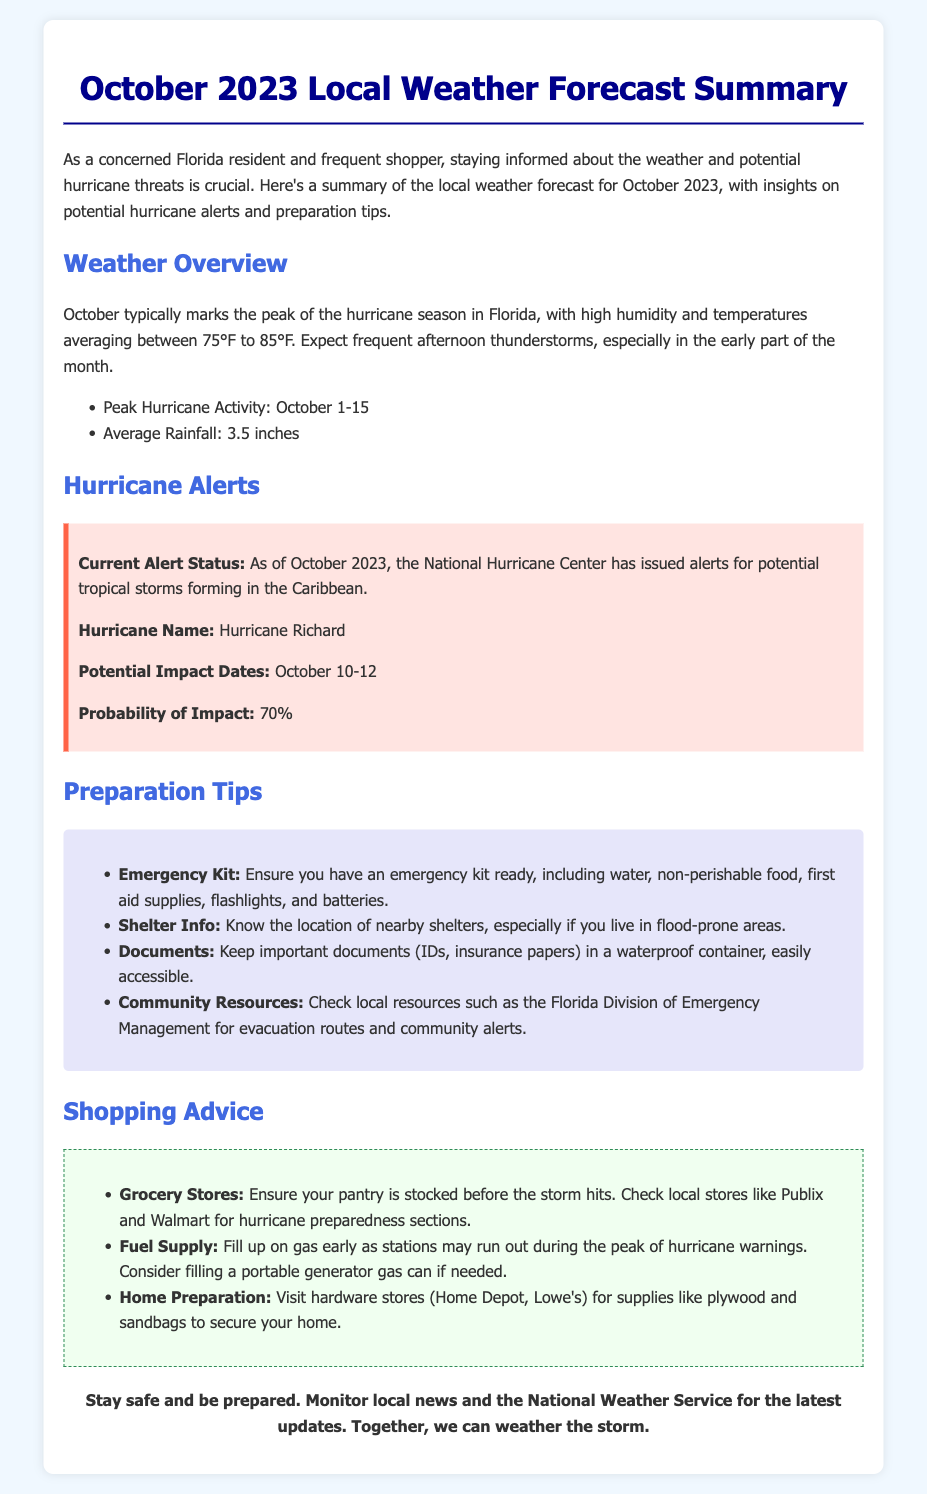What is the average temperature range for October? The document states that temperatures average between 75°F to 85°F in October.
Answer: 75°F to 85°F What is the average rainfall in October? The document specifies that the average rainfall for October is 3.5 inches.
Answer: 3.5 inches What is the name of the hurricane mentioned? The document indicates that the hurricane currently discussed is named Hurricane Richard.
Answer: Hurricane Richard What are the potential impact dates for Hurricane Richard? The document lists the potential impact dates as October 10-12.
Answer: October 10-12 What is the probability of impact for the hurricane? The document states the probability of impact as 70%.
Answer: 70% What should you include in your emergency kit? The document lists items such as water, non-perishable food, first aid supplies, flashlights, and batteries.
Answer: Water, non-perishable food, first aid supplies, flashlights, and batteries Where can you check for local resources regarding community alerts? The document mentions checking local resources like the Florida Division of Emergency Management.
Answer: Florida Division of Emergency Management What stores are suggested for purchasing hurricane supplies? The document recommends grocery stores like Publix and Walmart for stocking up on supplies.
Answer: Publix and Walmart What is one suggested preparation for your home? The document advises visiting hardware stores for supplies like plywood and sandbags to secure your home.
Answer: Plywood and sandbags 